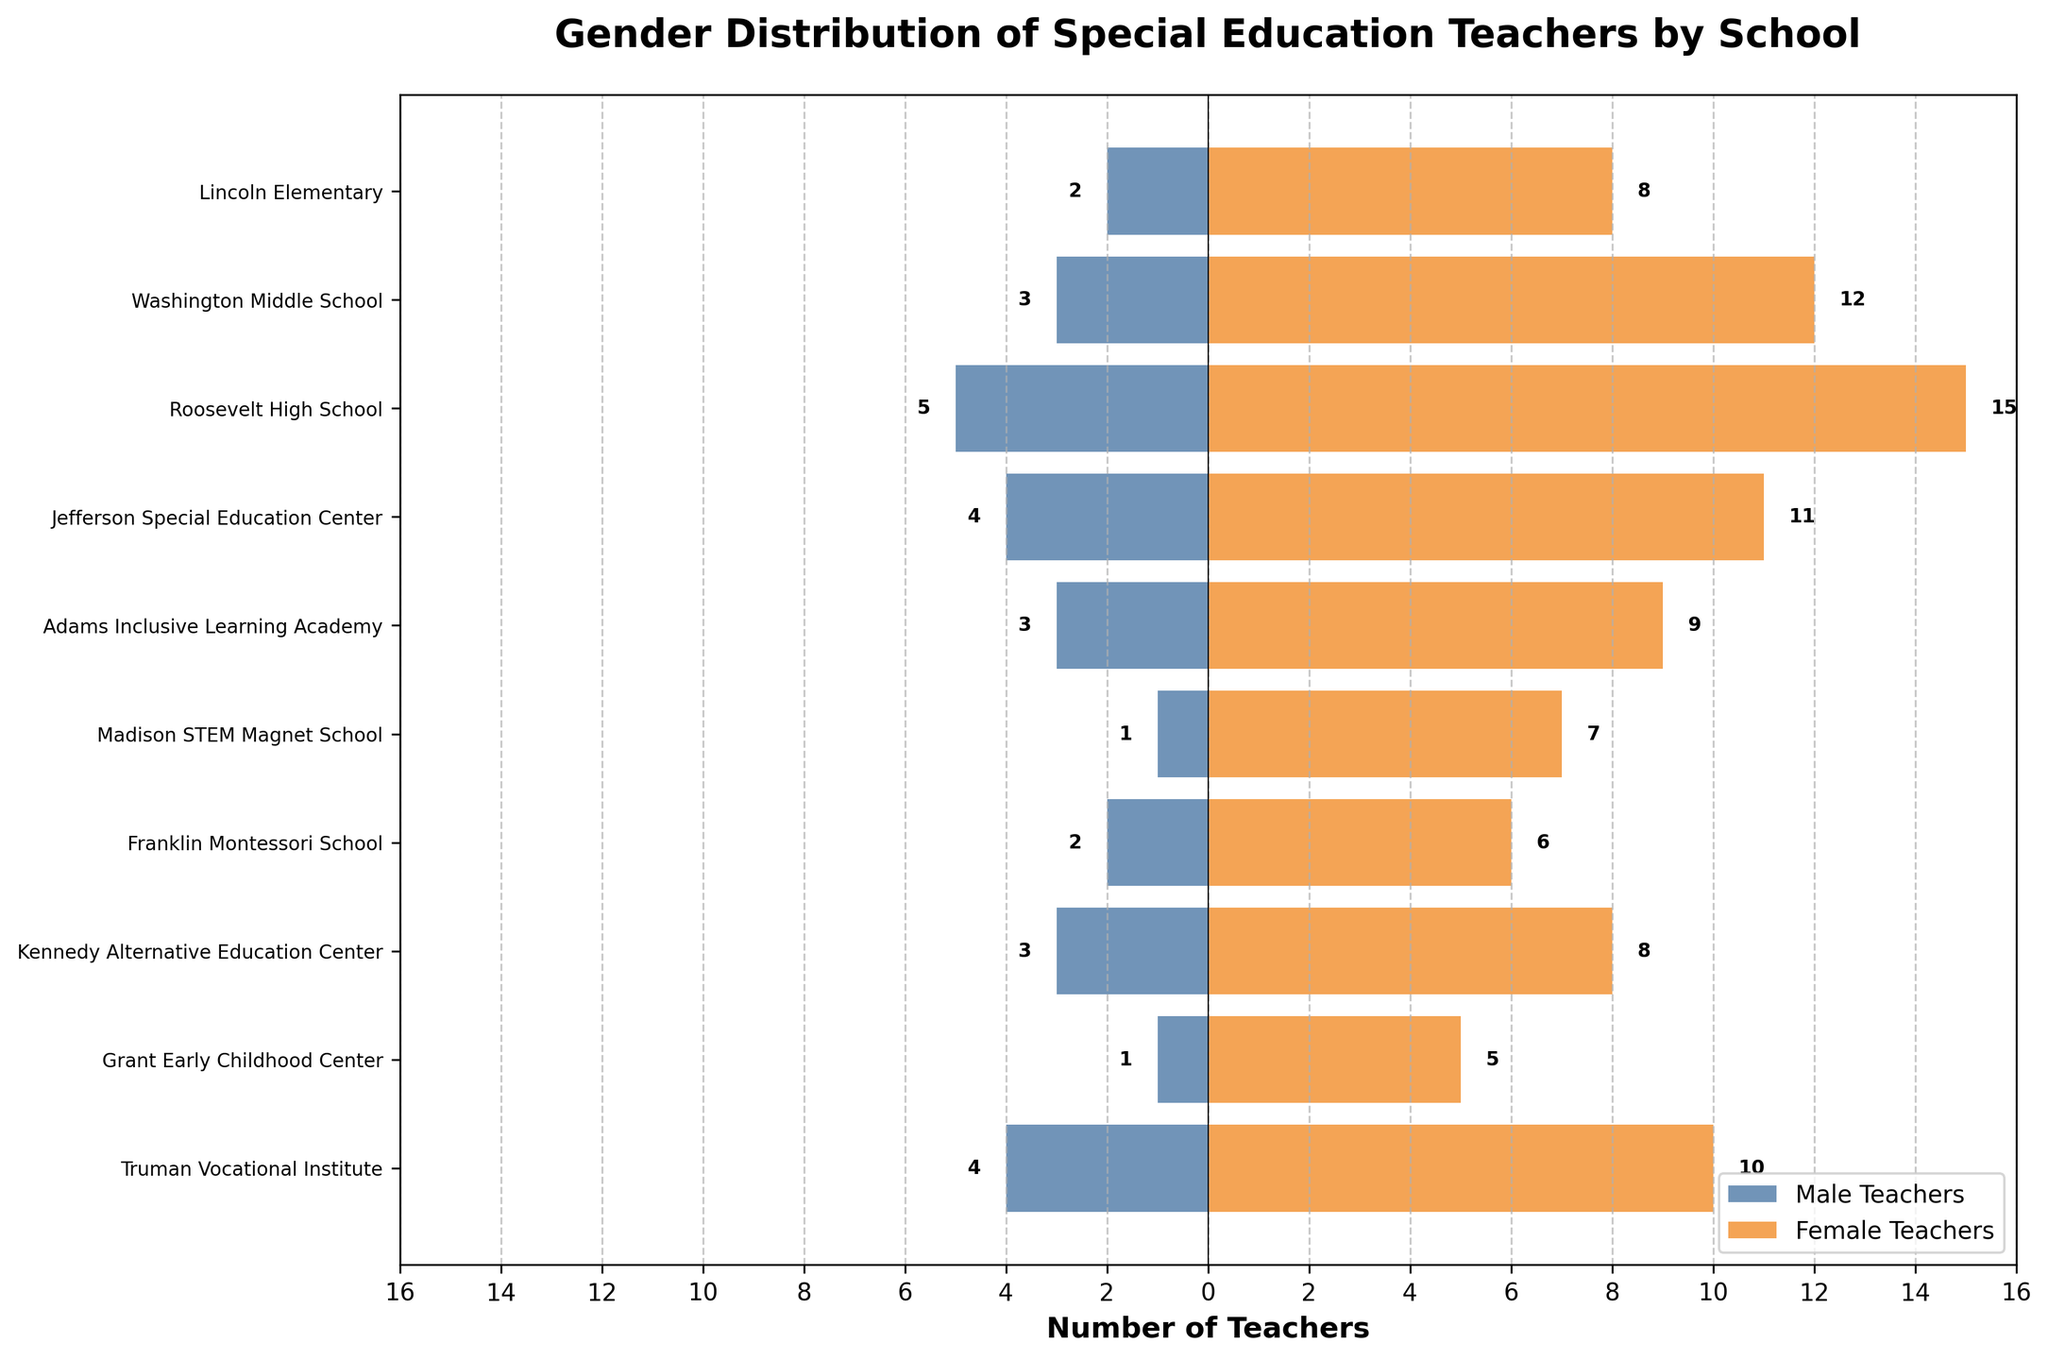What is the total number of male teachers at Roosevelt High School? The figure shows the number of male teachers at each school. For Roosevelt High School, this is indicated by the bar extending negatively to the left. The number next to the bar is 5.
Answer: 5 Which school has the highest number of female teachers? The female teachers' bars extend to the right, and the longest bar indicates the maximum number. Roosevelt High School has the longest bar for female teachers, with a value of 15.
Answer: Roosevelt High School What is the combined total number of special education teachers at Jefferson Special Education Center? The figure shows that Jefferson Special Education Center has 4 male teachers and 11 female teachers. Adding these gives 4 + 11 = 15.
Answer: 15 Which school has more male than female teachers? By observing the figure, we can see that at every school, the female teachers' bar extends further to the right than the male teachers' bar extends to the left. Therefore, no school has more male than female teachers.
Answer: None How many more female teachers are there than male teachers at Washington Middle School? Washington Middle School has 3 male teachers and 12 female teachers. The difference is calculated as 12 - 3 = 9.
Answer: 9 What is the average number of male teachers across all schools? To find the average, sum the number of male teachers from all schools and then divide by the number of schools: (2 + 3 + 5 + 4 + 3 + 1 + 2 + 3 + 1 + 4) / 10 = 28 / 10 = 2.8.
Answer: 2.8 Compare the number of male teachers at Lincoln Elementary and Madison STEM Magnet School. Which has more and by how much? Lincoln Elementary has 2 male teachers, and Madison STEM Magnet School has 1 male teacher. Lincoln Elementary has 1 more male teacher than Madison STEM Magnet School.
Answer: Lincoln Elementary by 1 What is the total number of female teachers in all schools combined? To find the total, sum the number of female teachers from all schools: 8 + 12 + 15 + 11 + 9 + 7 + 6 + 8 + 5 + 10 = 91.
Answer: 91 Which school has the fewest total special education teachers and what is the number? Grant Early Childhood Center has 1 male teacher and 5 female teachers, totaling 6. It is the smallest total number when compared with other schools.
Answer: Grant Early Childhood Center, 6 Between Jefferson Special Education Center and Kennedy Alternative Education Center, which has more female teachers, and by how many? Jefferson Special Education Center has 11 female teachers and Kennedy Alternative Education Center has 8. The difference is 11 - 8 = 3.
Answer: Jefferson Special Education Center by 3 